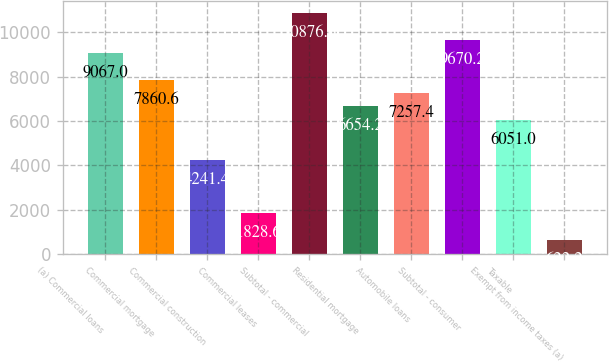Convert chart. <chart><loc_0><loc_0><loc_500><loc_500><bar_chart><fcel>(a) Commercial loans<fcel>Commercial mortgage<fcel>Commercial construction<fcel>Commercial leases<fcel>Subtotal - commercial<fcel>Residential mortgage<fcel>Automobile loans<fcel>Subtotal - consumer<fcel>Taxable<fcel>Exempt from income taxes (a)<nl><fcel>9067<fcel>7860.6<fcel>4241.4<fcel>1828.6<fcel>10876.6<fcel>6654.2<fcel>7257.4<fcel>9670.2<fcel>6051<fcel>622.2<nl></chart> 